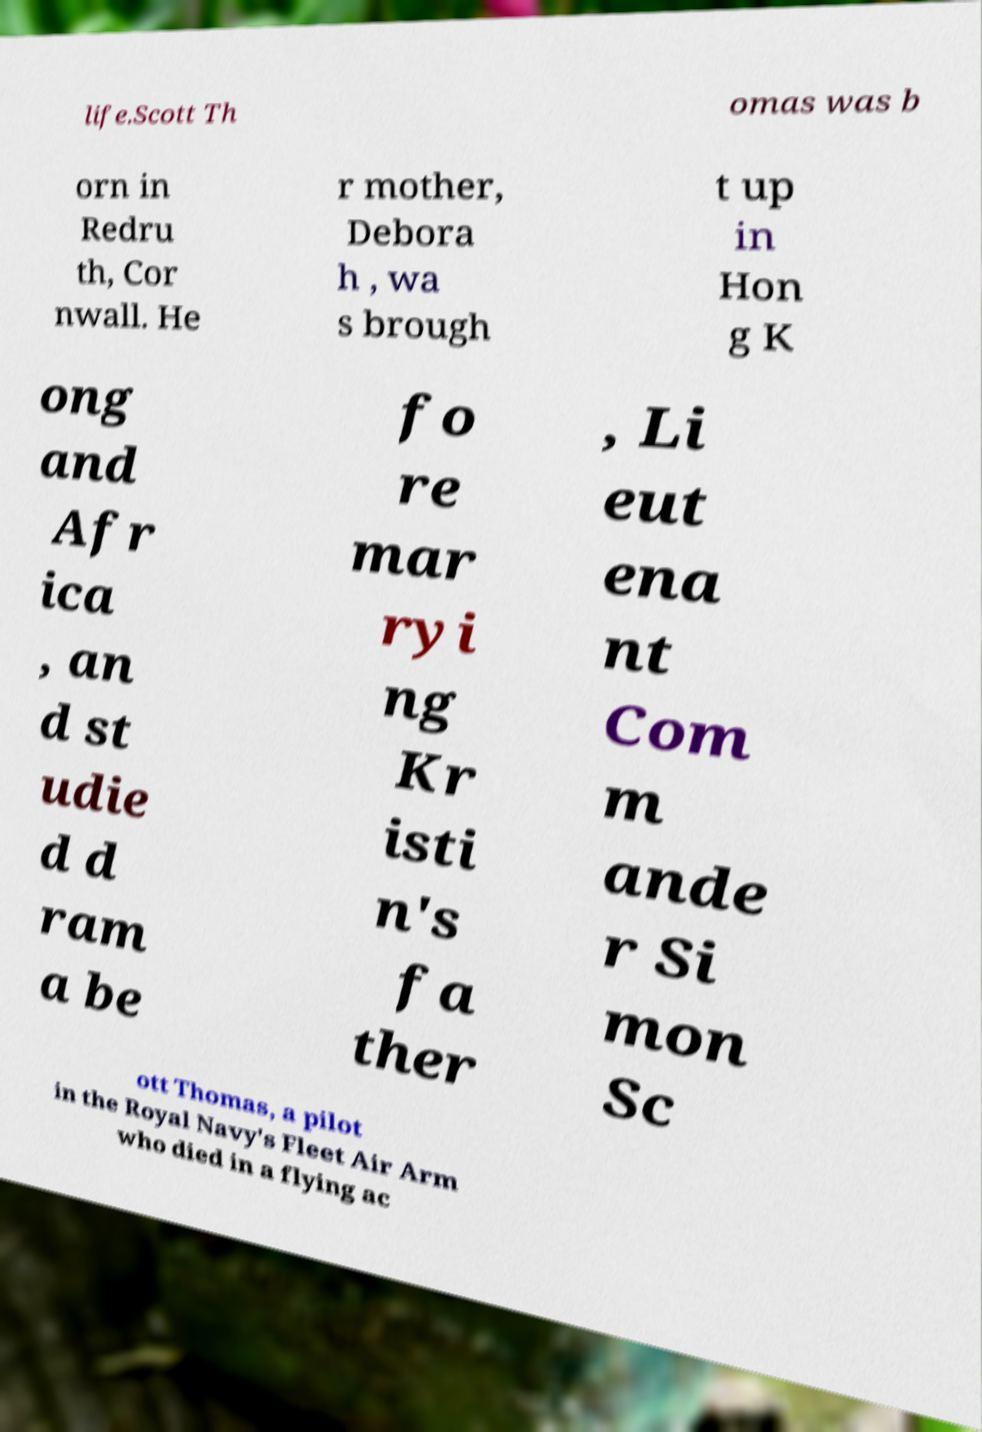Can you accurately transcribe the text from the provided image for me? life.Scott Th omas was b orn in Redru th, Cor nwall. He r mother, Debora h , wa s brough t up in Hon g K ong and Afr ica , an d st udie d d ram a be fo re mar ryi ng Kr isti n's fa ther , Li eut ena nt Com m ande r Si mon Sc ott Thomas, a pilot in the Royal Navy's Fleet Air Arm who died in a flying ac 